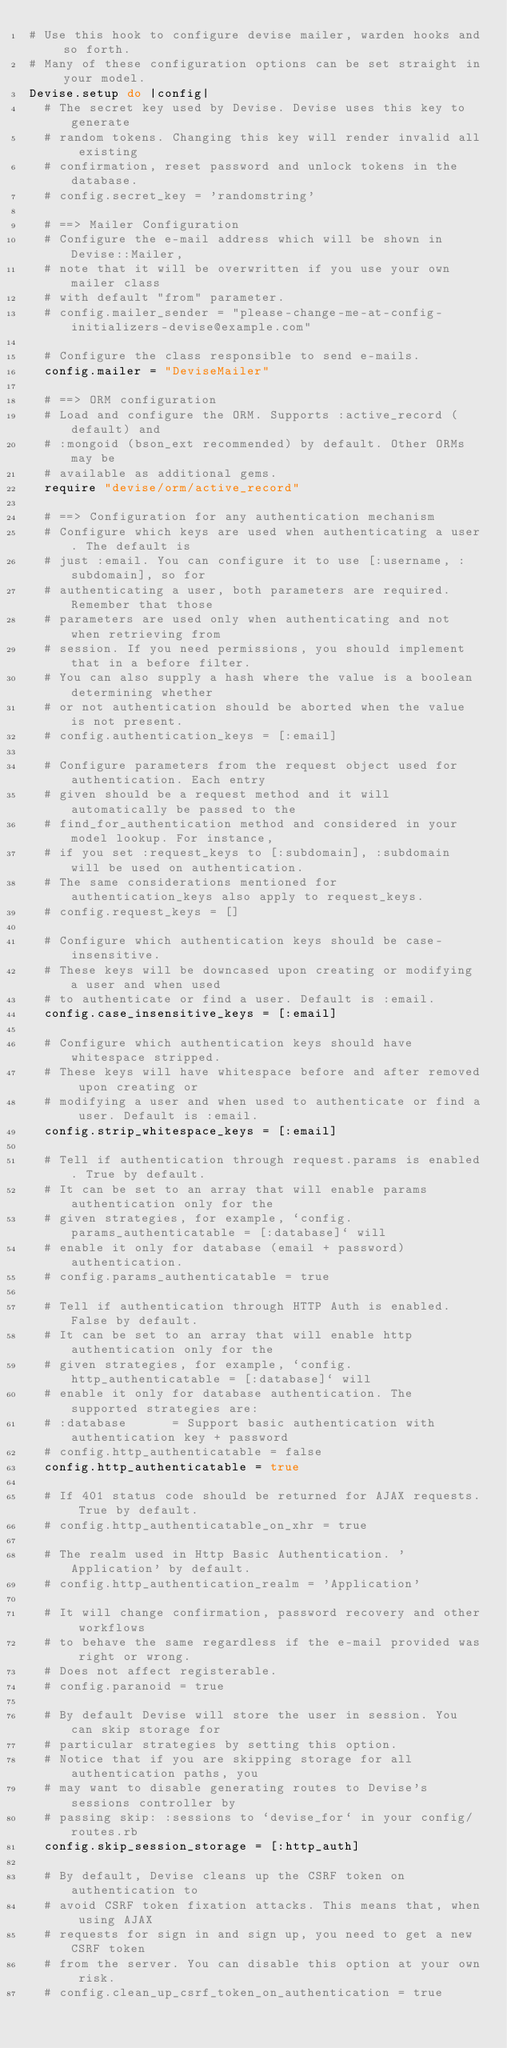Convert code to text. <code><loc_0><loc_0><loc_500><loc_500><_Ruby_># Use this hook to configure devise mailer, warden hooks and so forth.
# Many of these configuration options can be set straight in your model.
Devise.setup do |config|
  # The secret key used by Devise. Devise uses this key to generate
  # random tokens. Changing this key will render invalid all existing
  # confirmation, reset password and unlock tokens in the database.
  # config.secret_key = 'randomstring'

  # ==> Mailer Configuration
  # Configure the e-mail address which will be shown in Devise::Mailer,
  # note that it will be overwritten if you use your own mailer class
  # with default "from" parameter.
  # config.mailer_sender = "please-change-me-at-config-initializers-devise@example.com"

  # Configure the class responsible to send e-mails.
  config.mailer = "DeviseMailer"

  # ==> ORM configuration
  # Load and configure the ORM. Supports :active_record (default) and
  # :mongoid (bson_ext recommended) by default. Other ORMs may be
  # available as additional gems.
  require "devise/orm/active_record"

  # ==> Configuration for any authentication mechanism
  # Configure which keys are used when authenticating a user. The default is
  # just :email. You can configure it to use [:username, :subdomain], so for
  # authenticating a user, both parameters are required. Remember that those
  # parameters are used only when authenticating and not when retrieving from
  # session. If you need permissions, you should implement that in a before filter.
  # You can also supply a hash where the value is a boolean determining whether
  # or not authentication should be aborted when the value is not present.
  # config.authentication_keys = [:email]

  # Configure parameters from the request object used for authentication. Each entry
  # given should be a request method and it will automatically be passed to the
  # find_for_authentication method and considered in your model lookup. For instance,
  # if you set :request_keys to [:subdomain], :subdomain will be used on authentication.
  # The same considerations mentioned for authentication_keys also apply to request_keys.
  # config.request_keys = []

  # Configure which authentication keys should be case-insensitive.
  # These keys will be downcased upon creating or modifying a user and when used
  # to authenticate or find a user. Default is :email.
  config.case_insensitive_keys = [:email]

  # Configure which authentication keys should have whitespace stripped.
  # These keys will have whitespace before and after removed upon creating or
  # modifying a user and when used to authenticate or find a user. Default is :email.
  config.strip_whitespace_keys = [:email]

  # Tell if authentication through request.params is enabled. True by default.
  # It can be set to an array that will enable params authentication only for the
  # given strategies, for example, `config.params_authenticatable = [:database]` will
  # enable it only for database (email + password) authentication.
  # config.params_authenticatable = true

  # Tell if authentication through HTTP Auth is enabled. False by default.
  # It can be set to an array that will enable http authentication only for the
  # given strategies, for example, `config.http_authenticatable = [:database]` will
  # enable it only for database authentication. The supported strategies are:
  # :database      = Support basic authentication with authentication key + password
  # config.http_authenticatable = false
  config.http_authenticatable = true

  # If 401 status code should be returned for AJAX requests. True by default.
  # config.http_authenticatable_on_xhr = true

  # The realm used in Http Basic Authentication. 'Application' by default.
  # config.http_authentication_realm = 'Application'

  # It will change confirmation, password recovery and other workflows
  # to behave the same regardless if the e-mail provided was right or wrong.
  # Does not affect registerable.
  # config.paranoid = true

  # By default Devise will store the user in session. You can skip storage for
  # particular strategies by setting this option.
  # Notice that if you are skipping storage for all authentication paths, you
  # may want to disable generating routes to Devise's sessions controller by
  # passing skip: :sessions to `devise_for` in your config/routes.rb
  config.skip_session_storage = [:http_auth]

  # By default, Devise cleans up the CSRF token on authentication to
  # avoid CSRF token fixation attacks. This means that, when using AJAX
  # requests for sign in and sign up, you need to get a new CSRF token
  # from the server. You can disable this option at your own risk.
  # config.clean_up_csrf_token_on_authentication = true
</code> 